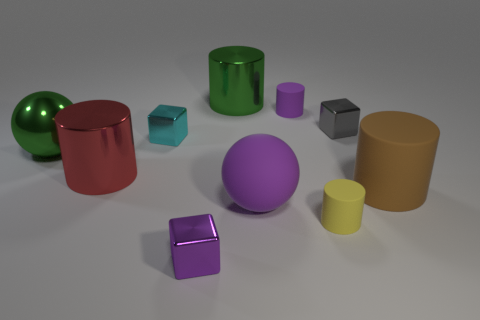What time of day does the lighting in the image suggest? The image has a soft, diffuse lighting that doesn't indicate a specific time of day. It looks more like a controlled studio lighting environment commonly used in 3D renderings or product photography. 